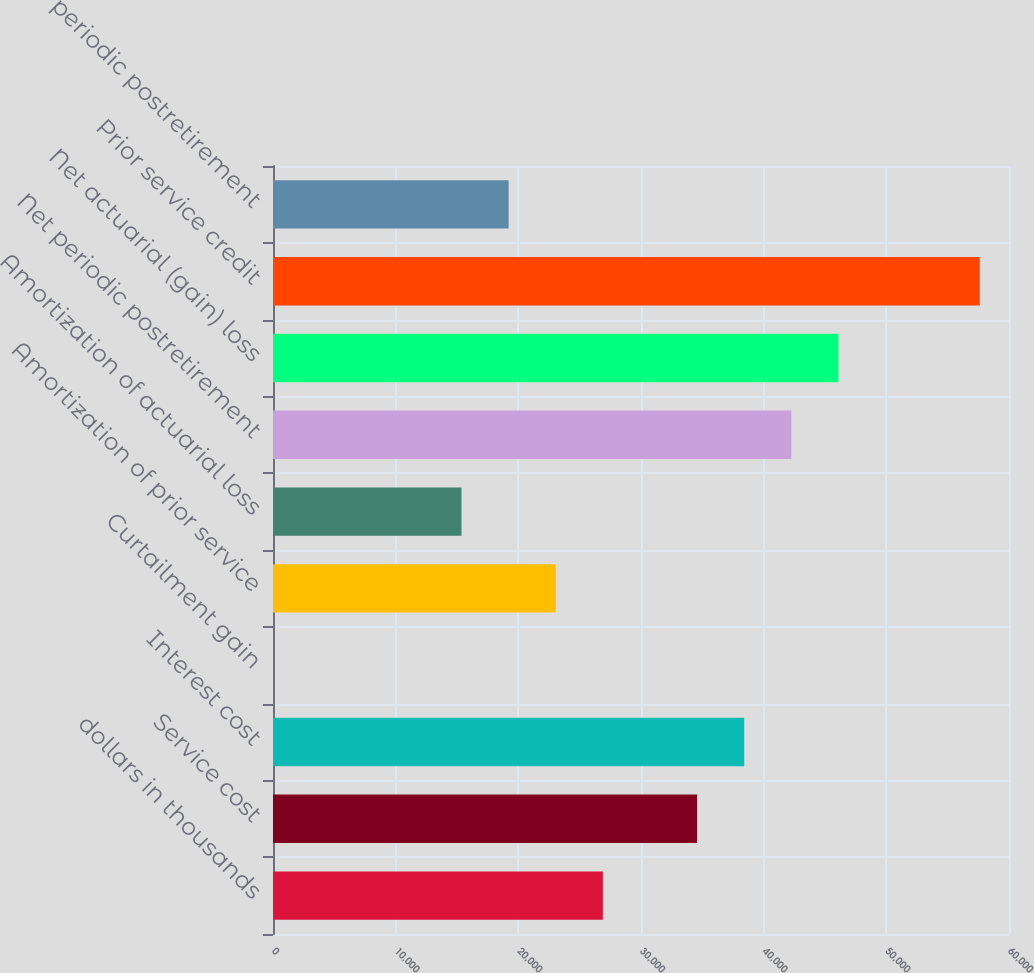Convert chart to OTSL. <chart><loc_0><loc_0><loc_500><loc_500><bar_chart><fcel>dollars in thousands<fcel>Service cost<fcel>Interest cost<fcel>Curtailment gain<fcel>Amortization of prior service<fcel>Amortization of actuarial loss<fcel>Net periodic postretirement<fcel>Net actuarial (gain) loss<fcel>Prior service credit<fcel>periodic postretirement<nl><fcel>26890.2<fcel>34572.8<fcel>38414<fcel>1.33<fcel>23049<fcel>15366.4<fcel>42255.3<fcel>46096.6<fcel>57620.4<fcel>19207.7<nl></chart> 